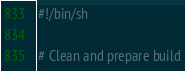<code> <loc_0><loc_0><loc_500><loc_500><_Bash_>#!/bin/sh

# Clean and prepare build</code> 